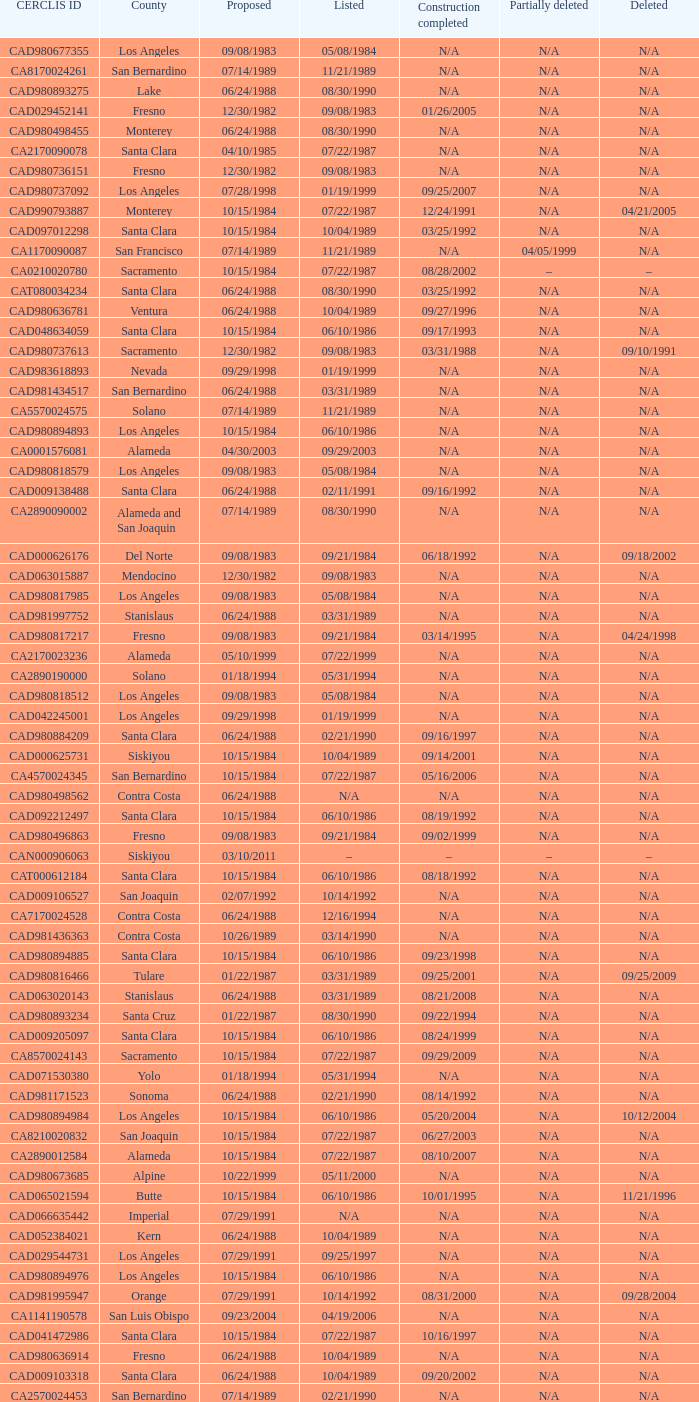What construction completed on 08/10/2007? 07/22/1987. 